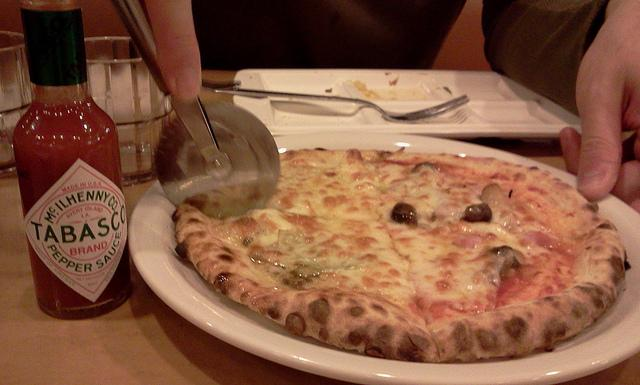The popular American brand of hot sauce is made up of what? tabasco 